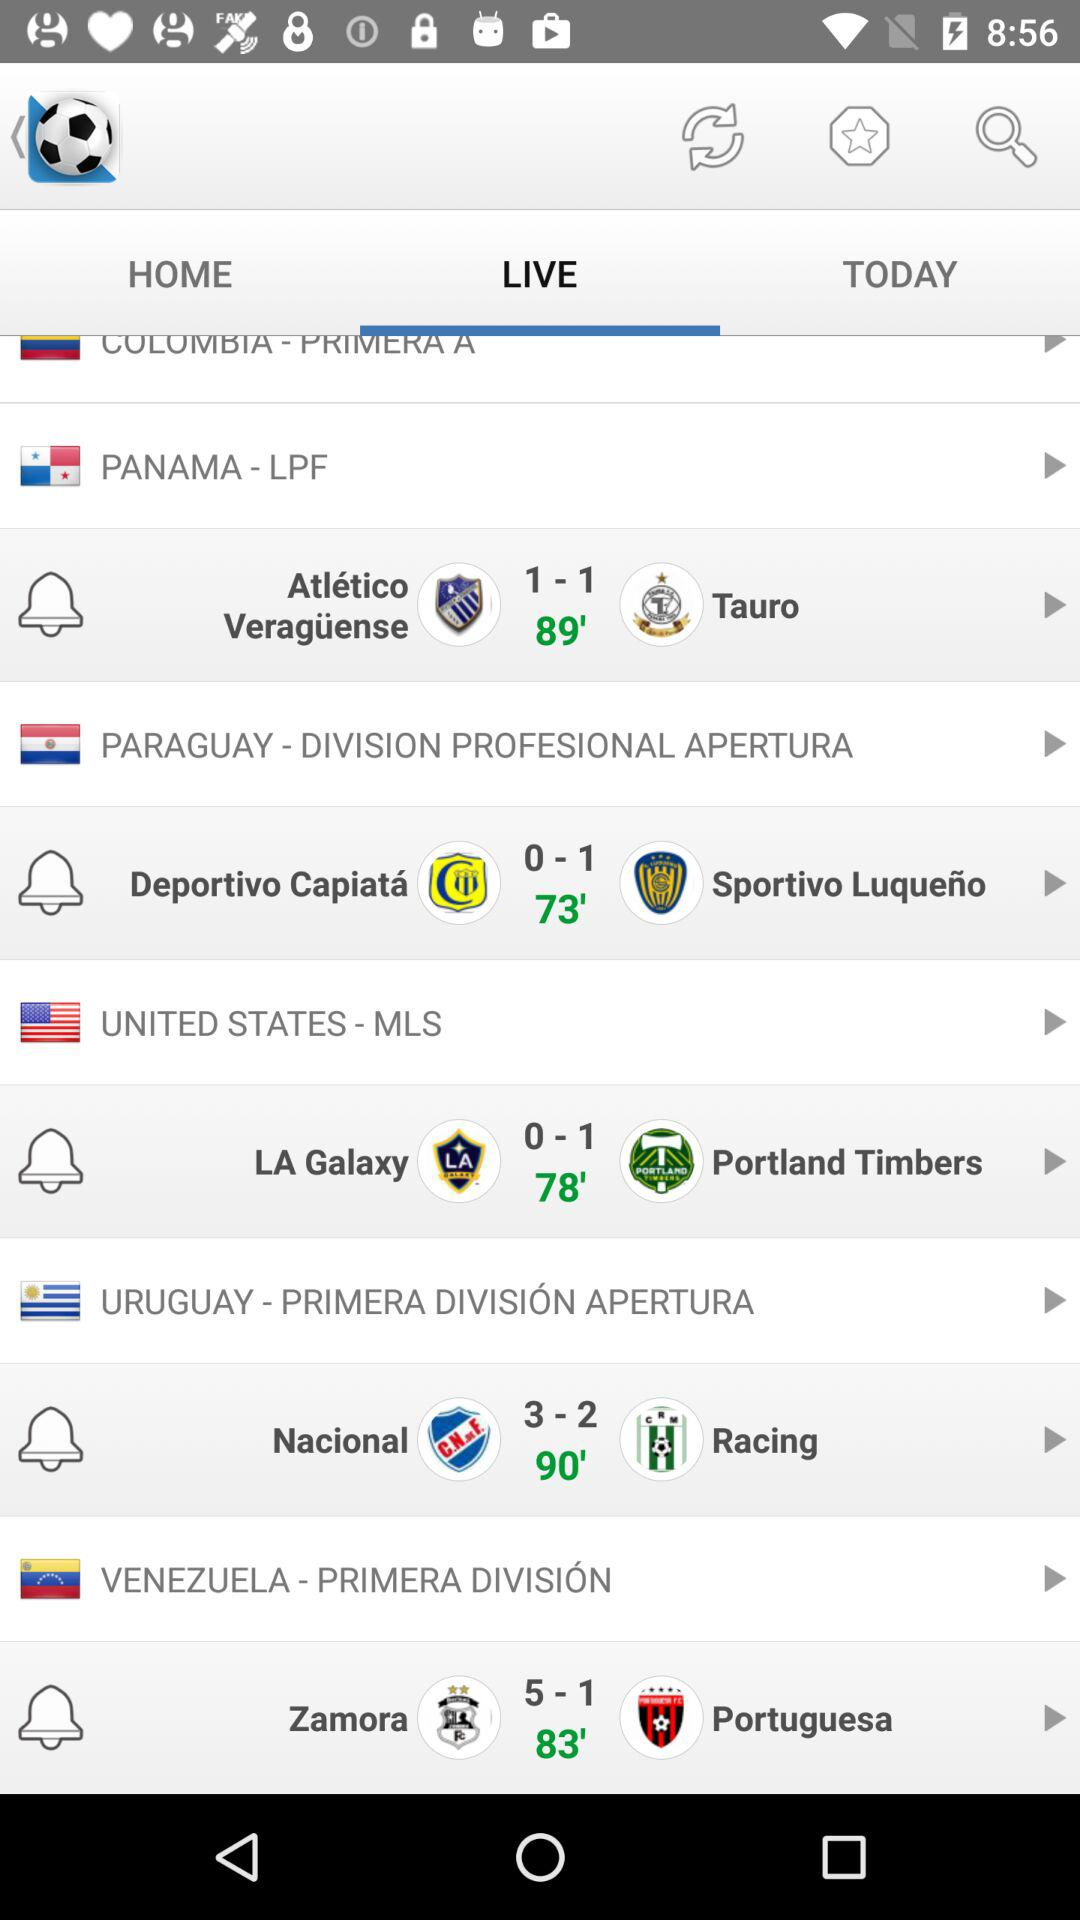How many more goals did Zamora score than Portuguesa?
Answer the question using a single word or phrase. 4 